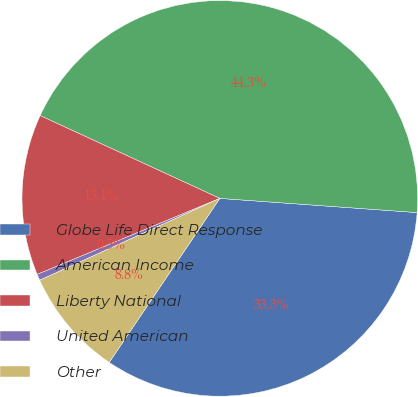Convert chart. <chart><loc_0><loc_0><loc_500><loc_500><pie_chart><fcel>Globe Life Direct Response<fcel>American Income<fcel>Liberty National<fcel>United American<fcel>Other<nl><fcel>33.3%<fcel>44.27%<fcel>13.15%<fcel>0.51%<fcel>8.77%<nl></chart> 